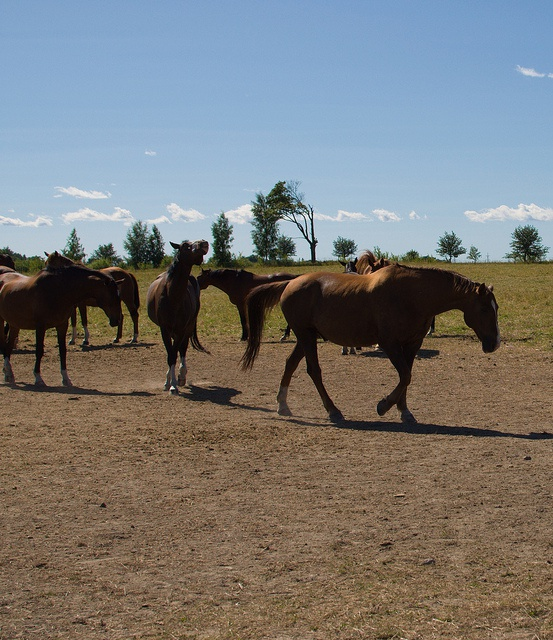Describe the objects in this image and their specific colors. I can see horse in darkgray, black, maroon, and gray tones, horse in darkgray, black, gray, maroon, and olive tones, horse in darkgray, black, maroon, and gray tones, horse in darkgray, black, maroon, olive, and gray tones, and horse in darkgray, black, olive, gray, and maroon tones in this image. 